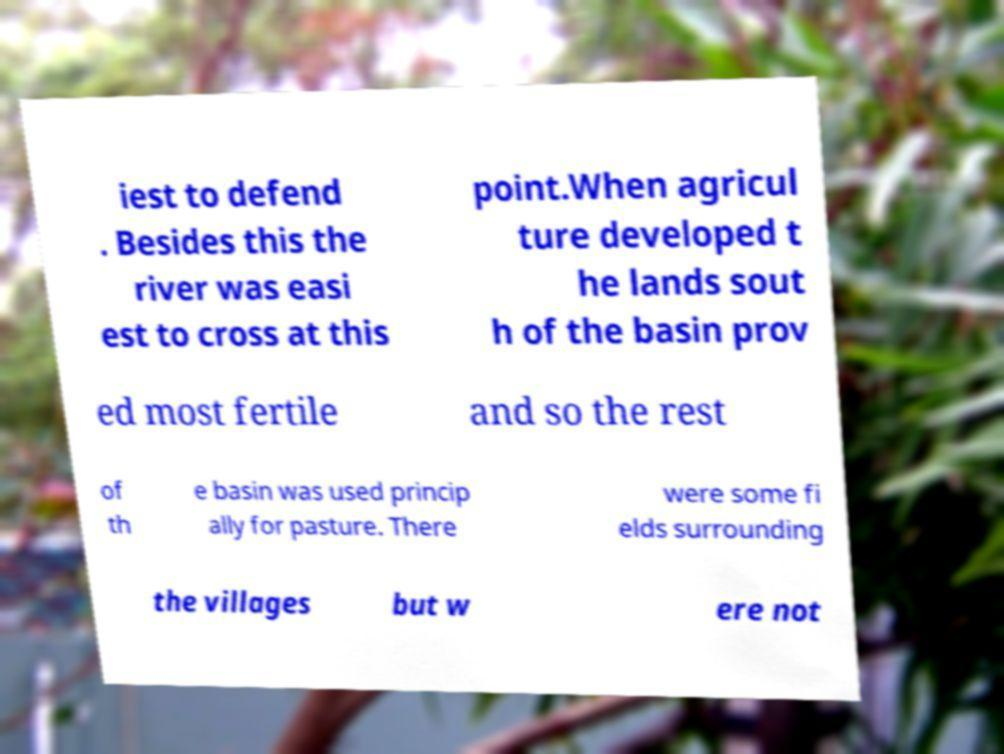Please identify and transcribe the text found in this image. iest to defend . Besides this the river was easi est to cross at this point.When agricul ture developed t he lands sout h of the basin prov ed most fertile and so the rest of th e basin was used princip ally for pasture. There were some fi elds surrounding the villages but w ere not 